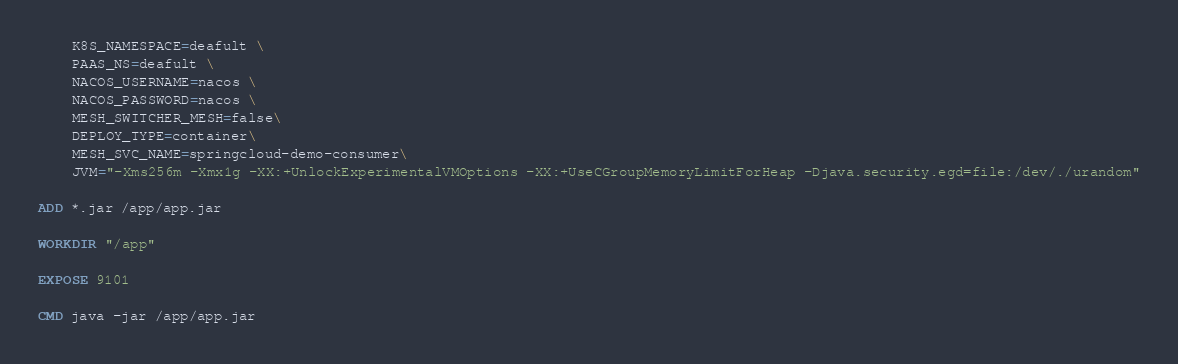<code> <loc_0><loc_0><loc_500><loc_500><_Dockerfile_>    K8S_NAMESPACE=deafult \
    PAAS_NS=deafult \
    NACOS_USERNAME=nacos \
    NACOS_PASSWORD=nacos \
    MESH_SWITCHER_MESH=false\
    DEPLOY_TYPE=container\
    MESH_SVC_NAME=springcloud-demo-consumer\
    JVM="-Xms256m -Xmx1g -XX:+UnlockExperimentalVMOptions -XX:+UseCGroupMemoryLimitForHeap -Djava.security.egd=file:/dev/./urandom"

ADD *.jar /app/app.jar

WORKDIR "/app"

EXPOSE 9101

CMD java -jar /app/app.jar
</code> 